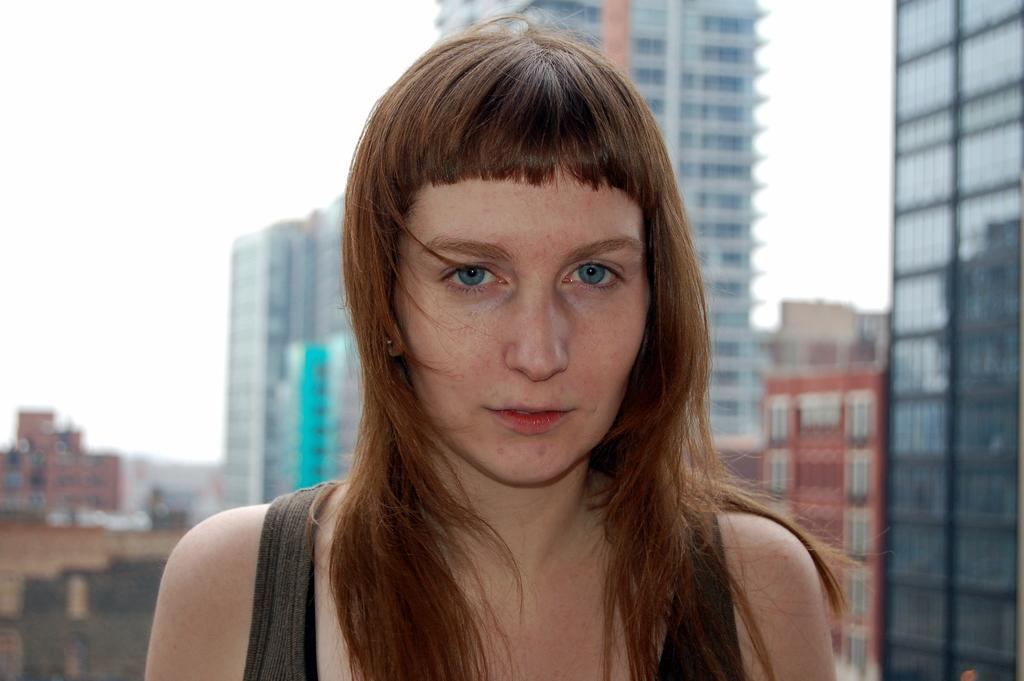Who is present in the image? There is a woman in the image. What structures can be seen in the image? There are buildings in the image. What can be seen in the background of the image? The sky is visible in the background of the image. What type of cord is being used by the woman in the image? There is no cord visible in the image, as the woman is not interacting with any objects that require a cord. 